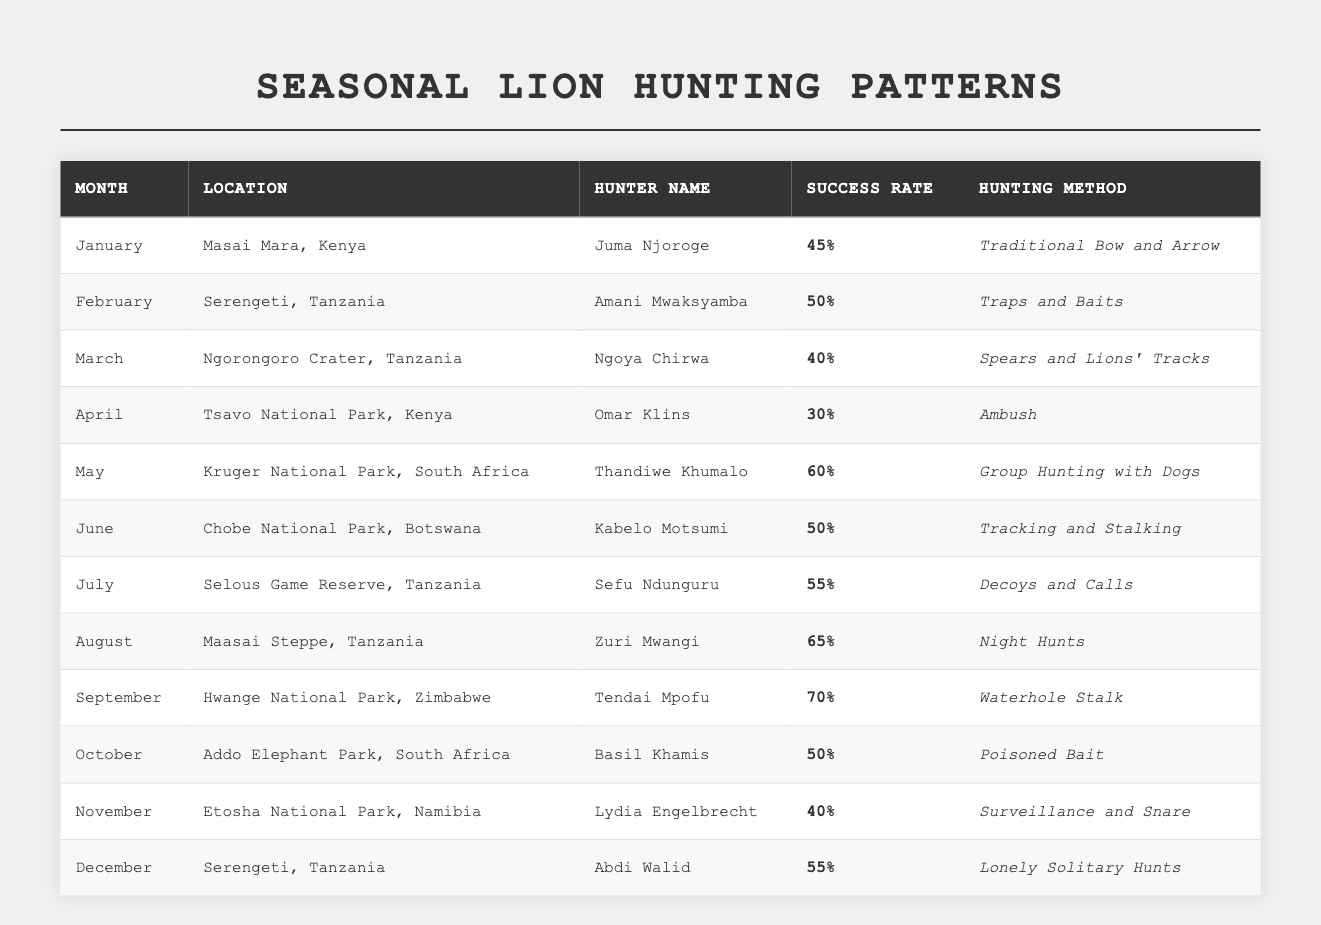What is the success rate of Thandiwe Khumalo in May? The table lists Thandiwe Khumalo's success rate in May as 60%.
Answer: 60% Which location had the highest success rate for lion hunting? By examining the table, September at Hwange National Park has the highest success rate of 70%.
Answer: Hwange National Park, 70% What is the average success rate of all hunters in the month of August? The success rate in August is 65% for Zuri Mwangi. Since there is only one entry for August, the average is simply 65%.
Answer: 65% How many different hunting methods are used throughout the year? The table shows various distinct methods. Five different methods are listed: Traditional Bow and Arrow, Traps and Baits, Spears and Lions' Tracks, Ambush, Group Hunting with Dogs, Tracking and Stalking, Decoys and Calls, Night Hunts, Waterhole Stalk, Poisoned Bait, Surveillance and Snare, and Lonely Solitary Hunts. Counting them gives a total of 11 distinct methods.
Answer: 11 What is the success rate difference between hunters in June and July? In June, Kabelo Motsumi had a success rate of 50%, while in July, Sefu Ndunguru had a success rate of 55%. The difference is 55% - 50% = 5%.
Answer: 5% Is there any month where the success rate was below 40%? The table indicates that the lowest success rate is 30% in April, confirming there is a month below 40%.
Answer: Yes Which month has the lowest success rate for lion hunting? By comparing all success rates listed in the table, April has the lowest rate at 30%.
Answer: April, 30% If we average the success rates for the first half of the year (January to June), what would it be? We calculate the sum of success rates for January (45%), February (50%), March (40%), April (30%), May (60%), and June (50%). The total is 275%. With 6 months, the average is 275% / 6 = approximately 45.83%.
Answer: 45.83% What type of hunting method was used most frequently by the hunters listed? The hunting methods listed in the table are predominantly unique, with no specific method repeated. Each method reflects a different strategy. Therefore, none is used more frequently than others, each being distinct.
Answer: None is repeated Which hunter had the highest success rate in a location outside Tanzania? Upon review, Thandiwe Khumalo in Kruger National Park, South Africa had the highest success rate at 60% which is outside Tanzania.
Answer: Thandiwe Khumalo, 60% 